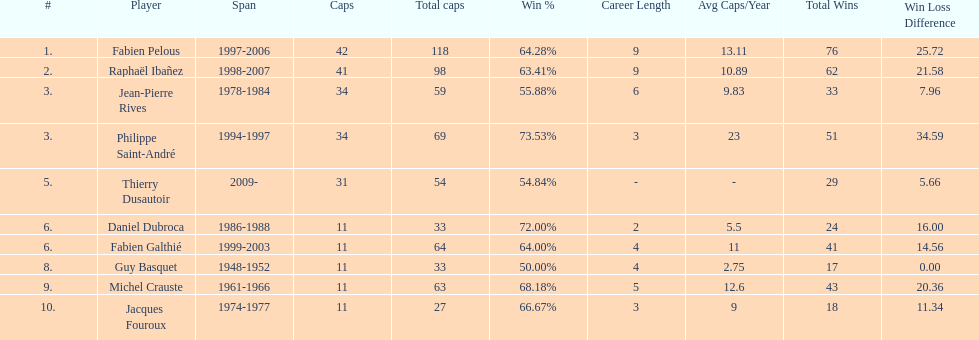Which player has the highest win percentage? Philippe Saint-André. 